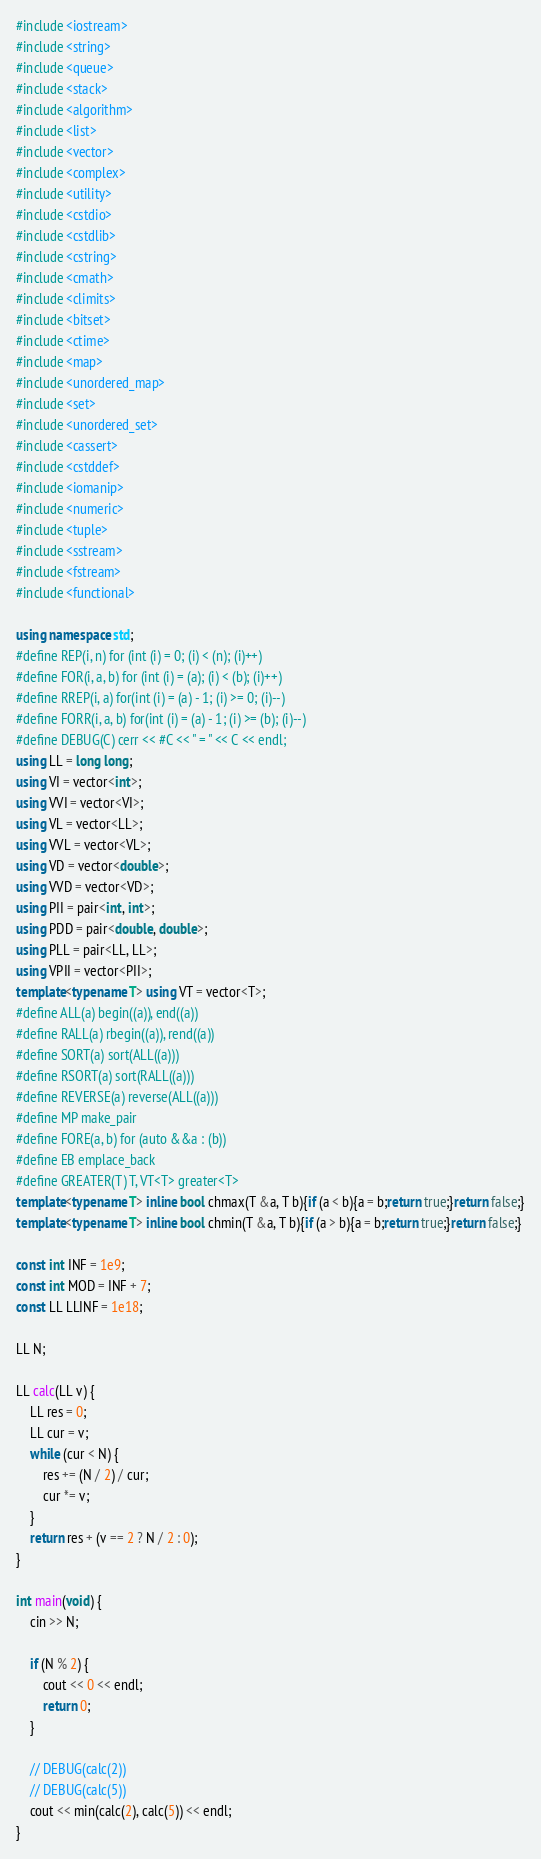<code> <loc_0><loc_0><loc_500><loc_500><_C++_>#include <iostream>
#include <string>
#include <queue>
#include <stack>
#include <algorithm>
#include <list>
#include <vector>
#include <complex>
#include <utility>
#include <cstdio>
#include <cstdlib>
#include <cstring>
#include <cmath>
#include <climits>
#include <bitset>
#include <ctime>
#include <map>
#include <unordered_map>
#include <set>
#include <unordered_set>
#include <cassert>
#include <cstddef>
#include <iomanip>
#include <numeric>
#include <tuple>
#include <sstream>
#include <fstream>
#include <functional>

using namespace std;
#define REP(i, n) for (int (i) = 0; (i) < (n); (i)++)
#define FOR(i, a, b) for (int (i) = (a); (i) < (b); (i)++)
#define RREP(i, a) for(int (i) = (a) - 1; (i) >= 0; (i)--)
#define FORR(i, a, b) for(int (i) = (a) - 1; (i) >= (b); (i)--)
#define DEBUG(C) cerr << #C << " = " << C << endl;
using LL = long long;
using VI = vector<int>;
using VVI = vector<VI>;
using VL = vector<LL>;
using VVL = vector<VL>;
using VD = vector<double>;
using VVD = vector<VD>;
using PII = pair<int, int>;
using PDD = pair<double, double>;
using PLL = pair<LL, LL>;
using VPII = vector<PII>;
template<typename T> using VT = vector<T>;
#define ALL(a) begin((a)), end((a))
#define RALL(a) rbegin((a)), rend((a))
#define SORT(a) sort(ALL((a)))
#define RSORT(a) sort(RALL((a)))
#define REVERSE(a) reverse(ALL((a)))
#define MP make_pair
#define FORE(a, b) for (auto &&a : (b))
#define EB emplace_back
#define GREATER(T) T, VT<T> greater<T>
template<typename T> inline bool chmax(T &a, T b){if (a < b){a = b;return true;}return false;}
template<typename T> inline bool chmin(T &a, T b){if (a > b){a = b;return true;}return false;}

const int INF = 1e9;
const int MOD = INF + 7;
const LL LLINF = 1e18;

LL N;

LL calc(LL v) {
    LL res = 0;
    LL cur = v;
    while (cur < N) {
        res += (N / 2) / cur;
        cur *= v;
    }
    return res + (v == 2 ? N / 2 : 0);
}

int main(void) {
    cin >> N;

    if (N % 2) {
        cout << 0 << endl;
        return 0;
    }

    // DEBUG(calc(2))
    // DEBUG(calc(5))
    cout << min(calc(2), calc(5)) << endl;
}
</code> 